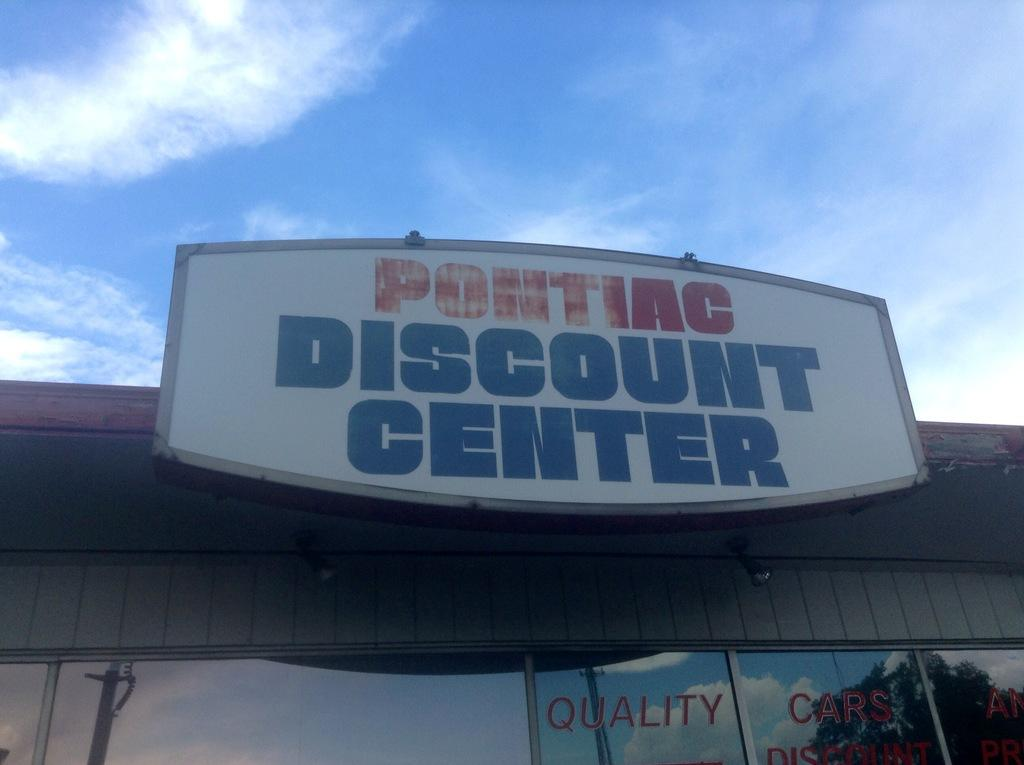<image>
Relay a brief, clear account of the picture shown. a building with a sign in front of it that says 'pontiac discount center' 